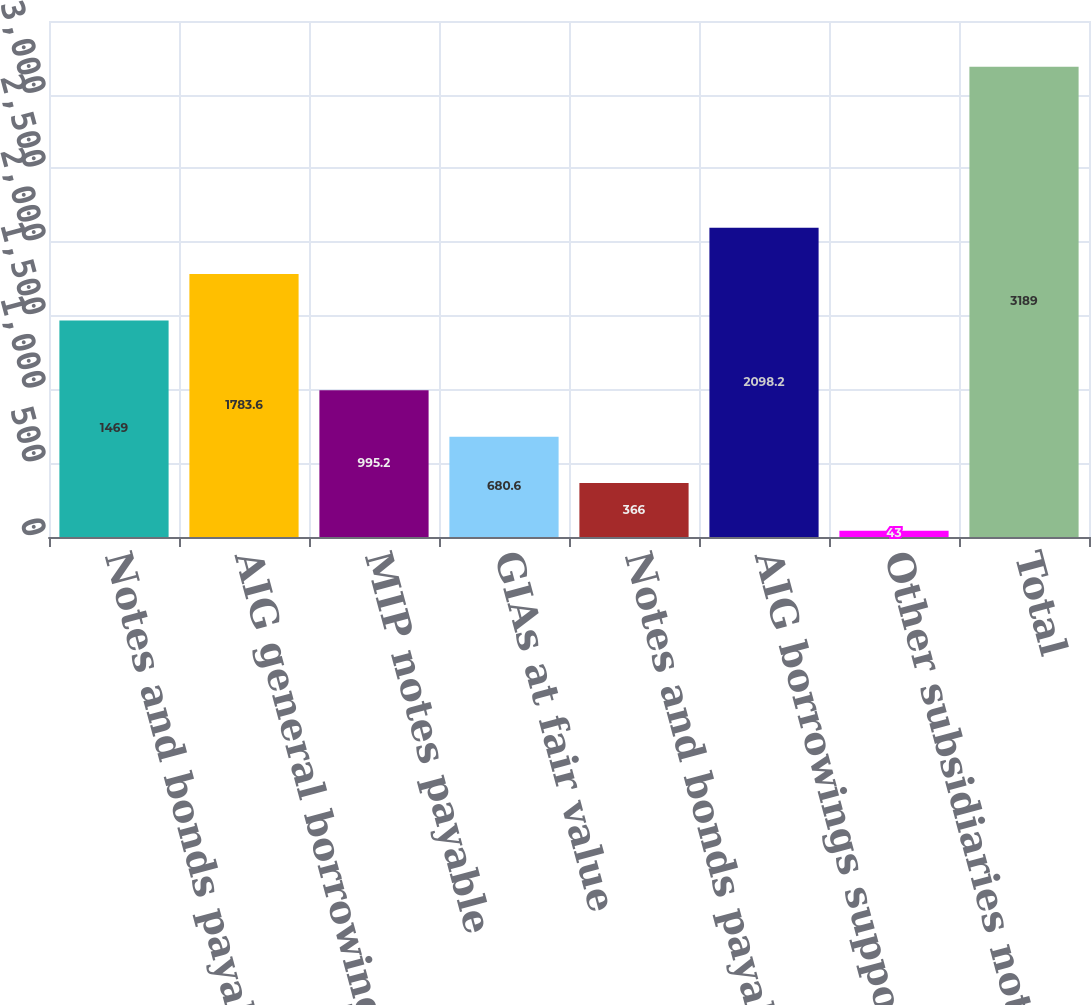Convert chart to OTSL. <chart><loc_0><loc_0><loc_500><loc_500><bar_chart><fcel>Notes and bonds payable<fcel>AIG general borrowings<fcel>MIP notes payable<fcel>GIAs at fair value<fcel>Notes and bonds payable at<fcel>AIG borrowings supported by<fcel>Other subsidiaries notes bonds<fcel>Total<nl><fcel>1469<fcel>1783.6<fcel>995.2<fcel>680.6<fcel>366<fcel>2098.2<fcel>43<fcel>3189<nl></chart> 